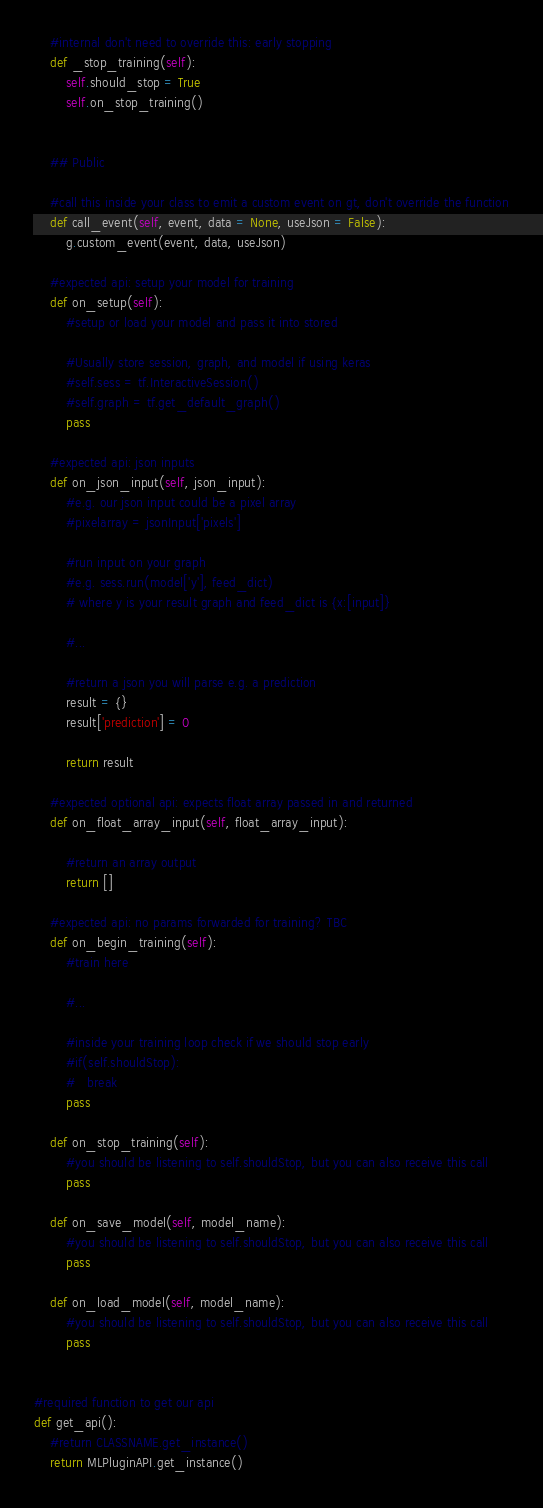<code> <loc_0><loc_0><loc_500><loc_500><_Python_>
	#internal don't need to override this: early stopping
	def _stop_training(self):
		self.should_stop = True
		self.on_stop_training()


	## Public
	
	#call this inside your class to emit a custom event on gt, don't override the function
	def call_event(self, event, data = None, useJson = False):
		g.custom_event(event, data, useJson)

	#expected api: setup your model for training
	def on_setup(self):
		#setup or load your model and pass it into stored
		
		#Usually store session, graph, and model if using keras
		#self.sess = tf.InteractiveSession()
		#self.graph = tf.get_default_graph()
		pass

	#expected api: json inputs
	def on_json_input(self, json_input):
		#e.g. our json input could be a pixel array
		#pixelarray = jsonInput['pixels']

		#run input on your graph
		#e.g. sess.run(model['y'], feed_dict)
		# where y is your result graph and feed_dict is {x:[input]}

		#...

		#return a json you will parse e.g. a prediction
		result = {}
		result['prediction'] = 0

		return result

	#expected optional api: expects float array passed in and returned
	def on_float_array_input(self, float_array_input):
		
		#return an array output
		return []

	#expected api: no params forwarded for training? TBC
	def on_begin_training(self):
		#train here

		#...

		#inside your training loop check if we should stop early
		#if(self.shouldStop):
		#	break
		pass

	def on_stop_training(self):
		#you should be listening to self.shouldStop, but you can also receive this call
		pass

	def on_save_model(self, model_name):
		#you should be listening to self.shouldStop, but you can also receive this call
		pass

	def on_load_model(self, model_name):
		#you should be listening to self.shouldStop, but you can also receive this call
		pass


#required function to get our api
def get_api():
	#return CLASSNAME.get_instance()
	return MLPluginAPI.get_instance()
</code> 